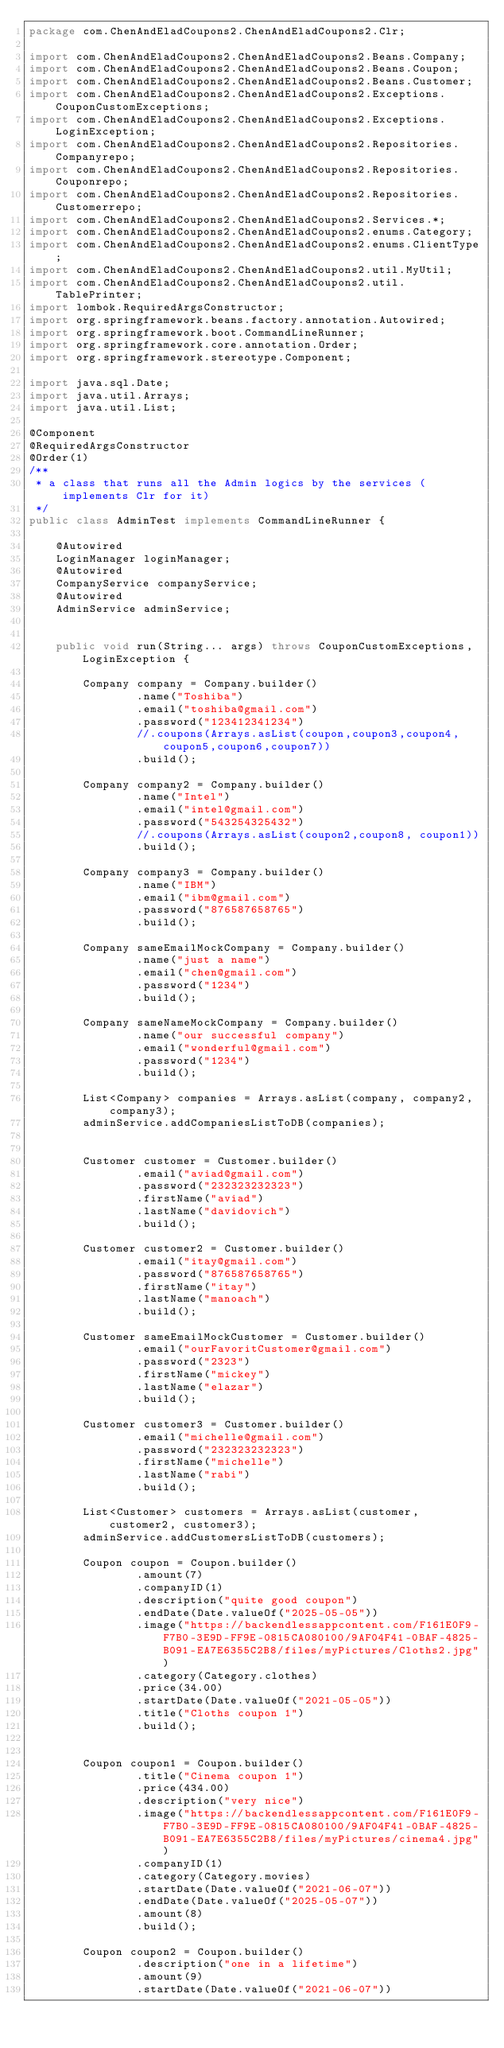Convert code to text. <code><loc_0><loc_0><loc_500><loc_500><_Java_>package com.ChenAndEladCoupons2.ChenAndEladCoupons2.Clr;

import com.ChenAndEladCoupons2.ChenAndEladCoupons2.Beans.Company;
import com.ChenAndEladCoupons2.ChenAndEladCoupons2.Beans.Coupon;
import com.ChenAndEladCoupons2.ChenAndEladCoupons2.Beans.Customer;
import com.ChenAndEladCoupons2.ChenAndEladCoupons2.Exceptions.CouponCustomExceptions;
import com.ChenAndEladCoupons2.ChenAndEladCoupons2.Exceptions.LoginException;
import com.ChenAndEladCoupons2.ChenAndEladCoupons2.Repositories.Companyrepo;
import com.ChenAndEladCoupons2.ChenAndEladCoupons2.Repositories.Couponrepo;
import com.ChenAndEladCoupons2.ChenAndEladCoupons2.Repositories.Customerrepo;
import com.ChenAndEladCoupons2.ChenAndEladCoupons2.Services.*;
import com.ChenAndEladCoupons2.ChenAndEladCoupons2.enums.Category;
import com.ChenAndEladCoupons2.ChenAndEladCoupons2.enums.ClientType;
import com.ChenAndEladCoupons2.ChenAndEladCoupons2.util.MyUtil;
import com.ChenAndEladCoupons2.ChenAndEladCoupons2.util.TablePrinter;
import lombok.RequiredArgsConstructor;
import org.springframework.beans.factory.annotation.Autowired;
import org.springframework.boot.CommandLineRunner;
import org.springframework.core.annotation.Order;
import org.springframework.stereotype.Component;

import java.sql.Date;
import java.util.Arrays;
import java.util.List;

@Component
@RequiredArgsConstructor
@Order(1)
/**
 * a class that runs all the Admin logics by the services (implements Clr for it)
 */
public class AdminTest implements CommandLineRunner {

    @Autowired
    LoginManager loginManager;
    @Autowired
    CompanyService companyService;
    @Autowired
    AdminService adminService;


    public void run(String... args) throws CouponCustomExceptions, LoginException {

        Company company = Company.builder()
                .name("Toshiba")
                .email("toshiba@gmail.com")
                .password("123412341234")
                //.coupons(Arrays.asList(coupon,coupon3,coupon4,coupon5,coupon6,coupon7))
                .build();

        Company company2 = Company.builder()
                .name("Intel")
                .email("intel@gmail.com")
                .password("543254325432")
                //.coupons(Arrays.asList(coupon2,coupon8, coupon1))
                .build();

        Company company3 = Company.builder()
                .name("IBM")
                .email("ibm@gmail.com")
                .password("876587658765")
                .build();

        Company sameEmailMockCompany = Company.builder()
                .name("just a name")
                .email("chen@gmail.com")
                .password("1234")
                .build();

        Company sameNameMockCompany = Company.builder()
                .name("our successful company")
                .email("wonderful@gmail.com")
                .password("1234")
                .build();

        List<Company> companies = Arrays.asList(company, company2, company3);
        adminService.addCompaniesListToDB(companies);


        Customer customer = Customer.builder()
                .email("aviad@gmail.com")
                .password("232323232323")
                .firstName("aviad")
                .lastName("davidovich")
                .build();

        Customer customer2 = Customer.builder()
                .email("itay@gmail.com")
                .password("876587658765")
                .firstName("itay")
                .lastName("manoach")
                .build();

        Customer sameEmailMockCustomer = Customer.builder()
                .email("ourFavoritCustomer@gmail.com")
                .password("2323")
                .firstName("mickey")
                .lastName("elazar")
                .build();

        Customer customer3 = Customer.builder()
                .email("michelle@gmail.com")
                .password("232323232323")
                .firstName("michelle")
                .lastName("rabi")
                .build();

        List<Customer> customers = Arrays.asList(customer, customer2, customer3);
        adminService.addCustomersListToDB(customers);

        Coupon coupon = Coupon.builder()
                .amount(7)
                .companyID(1)
                .description("quite good coupon")
                .endDate(Date.valueOf("2025-05-05"))
                .image("https://backendlessappcontent.com/F161E0F9-F7B0-3E9D-FF9E-0815CA080100/9AF04F41-0BAF-4825-B091-EA7E6355C2B8/files/myPictures/Cloths2.jpg")
                .category(Category.clothes)
                .price(34.00)
                .startDate(Date.valueOf("2021-05-05"))
                .title("Cloths coupon 1")
                .build();


        Coupon coupon1 = Coupon.builder()
                .title("Cinema coupon 1")
                .price(434.00)
                .description("very nice")
                .image("https://backendlessappcontent.com/F161E0F9-F7B0-3E9D-FF9E-0815CA080100/9AF04F41-0BAF-4825-B091-EA7E6355C2B8/files/myPictures/cinema4.jpg")
                .companyID(1)
                .category(Category.movies)
                .startDate(Date.valueOf("2021-06-07"))
                .endDate(Date.valueOf("2025-05-07"))
                .amount(8)
                .build();

        Coupon coupon2 = Coupon.builder()
                .description("one in a lifetime")
                .amount(9)
                .startDate(Date.valueOf("2021-06-07"))</code> 